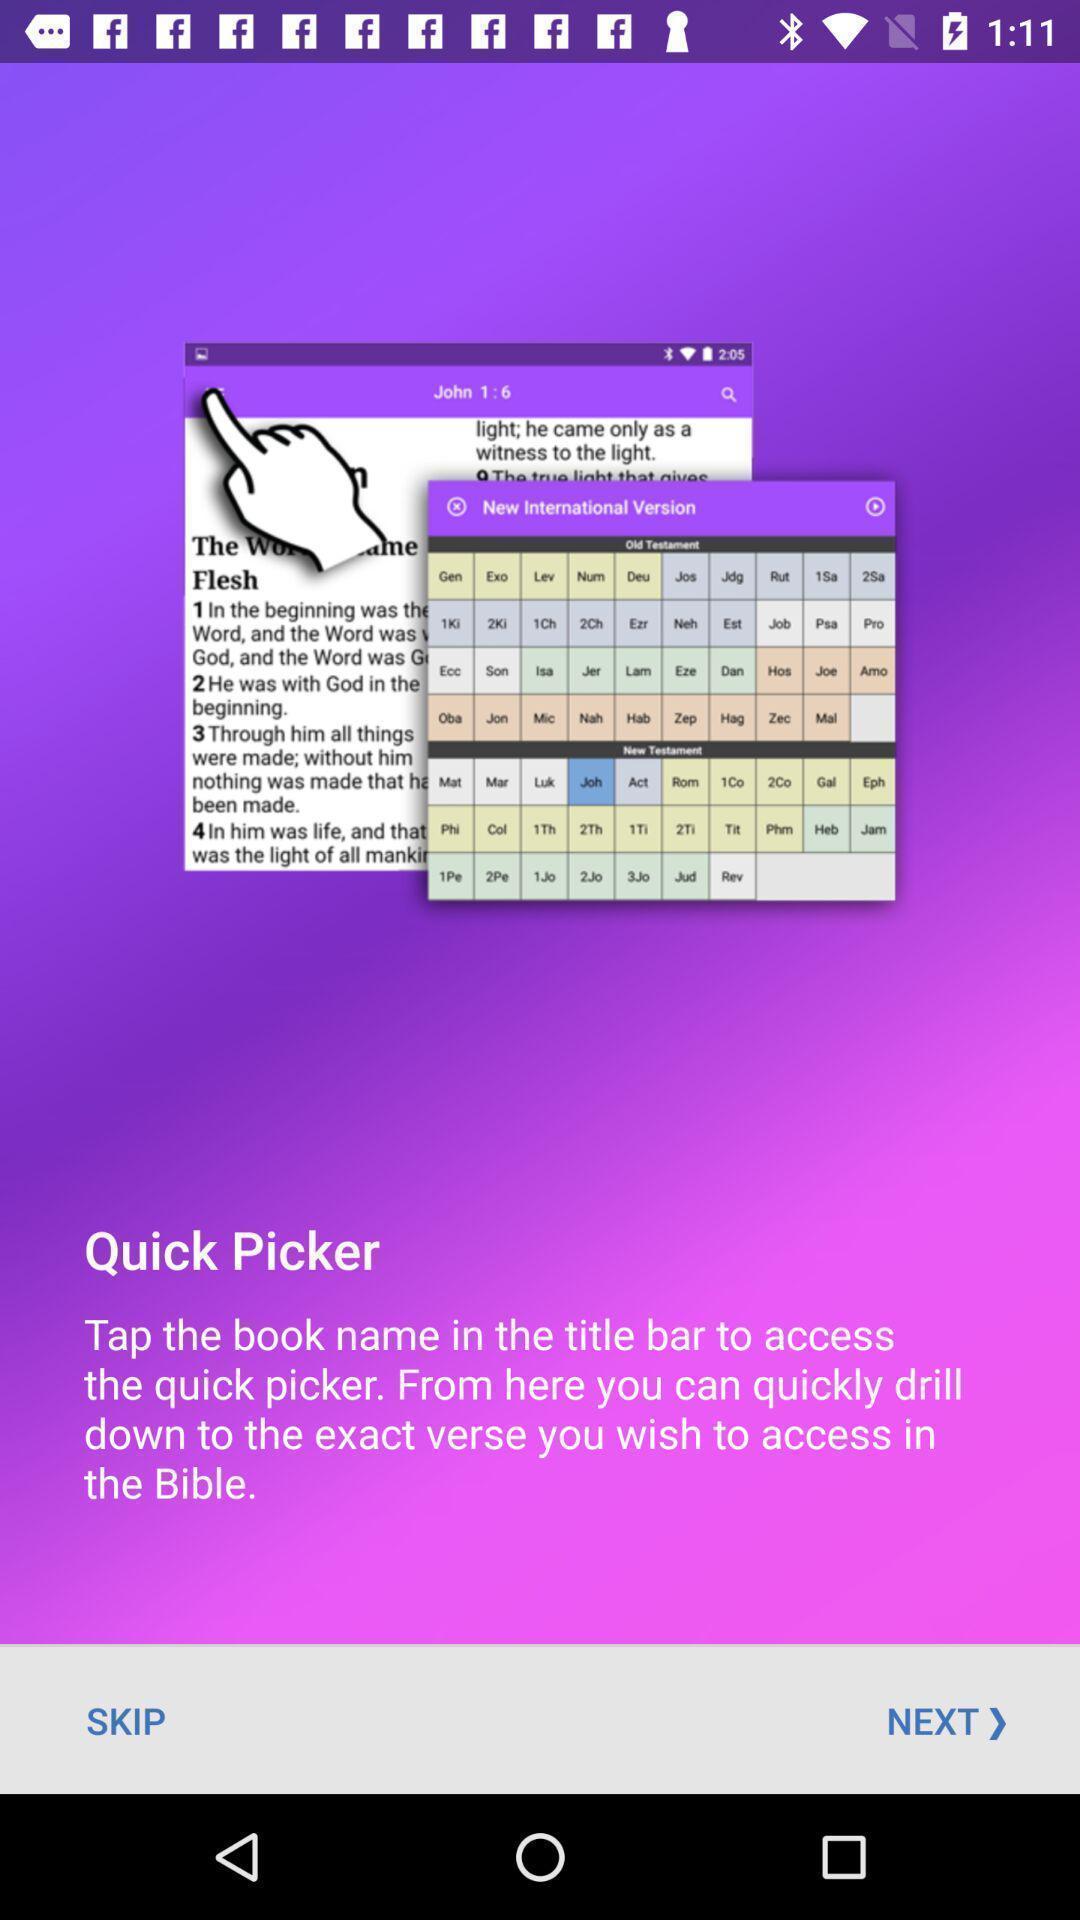Summarize the main components in this picture. Welcome page. 